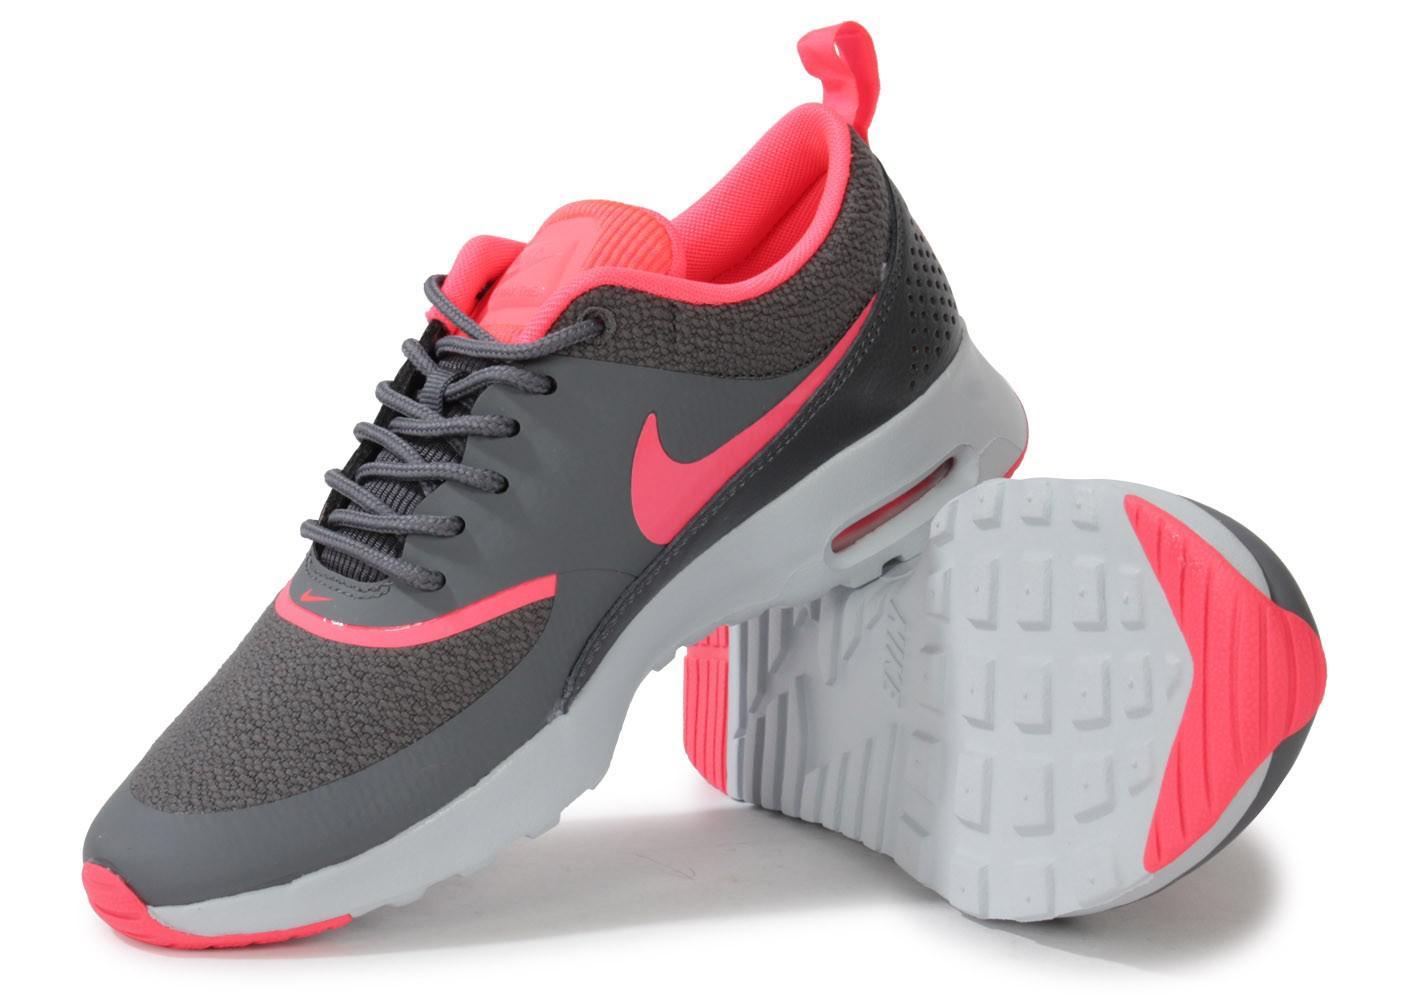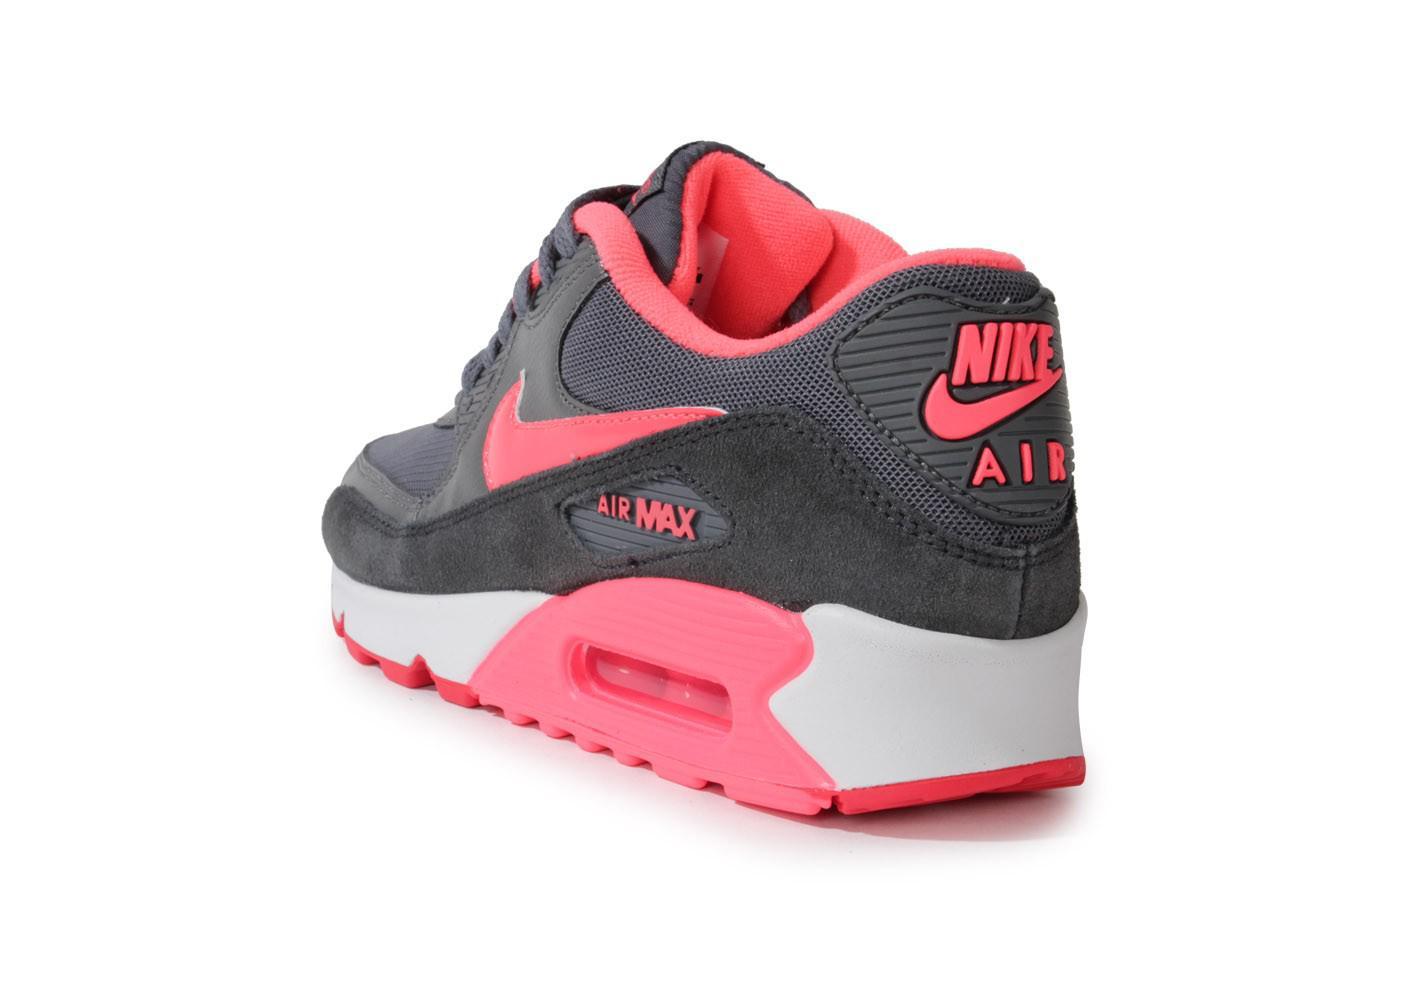The first image is the image on the left, the second image is the image on the right. For the images displayed, is the sentence "In one image a shoe is flipped on its side." factually correct? Answer yes or no. Yes. The first image is the image on the left, the second image is the image on the right. Analyze the images presented: Is the assertion "All shoes feature hot pink and gray in their design, and all shoes have a curved boomerang-shaped logo on the side." valid? Answer yes or no. Yes. 